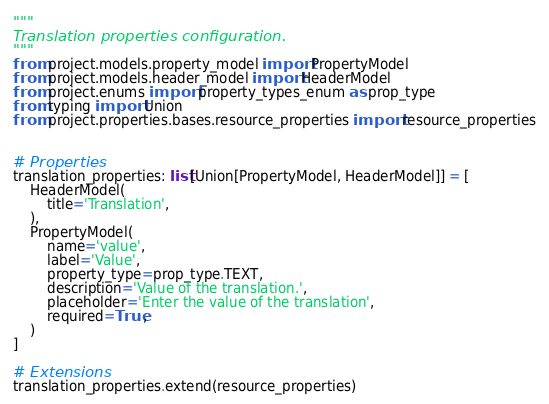<code> <loc_0><loc_0><loc_500><loc_500><_Python_>"""
Translation properties configuration.
"""
from project.models.property_model import PropertyModel
from project.models.header_model import HeaderModel
from project.enums import property_types_enum as prop_type
from typing import Union
from project.properties.bases.resource_properties import resource_properties


# Properties
translation_properties: list[Union[PropertyModel, HeaderModel]] = [
    HeaderModel(
        title='Translation',
    ),
    PropertyModel(
        name='value',
        label='Value',
        property_type=prop_type.TEXT,
        description='Value of the translation.',
        placeholder='Enter the value of the translation',
        required=True,
    )
]

# Extensions
translation_properties.extend(resource_properties)
</code> 